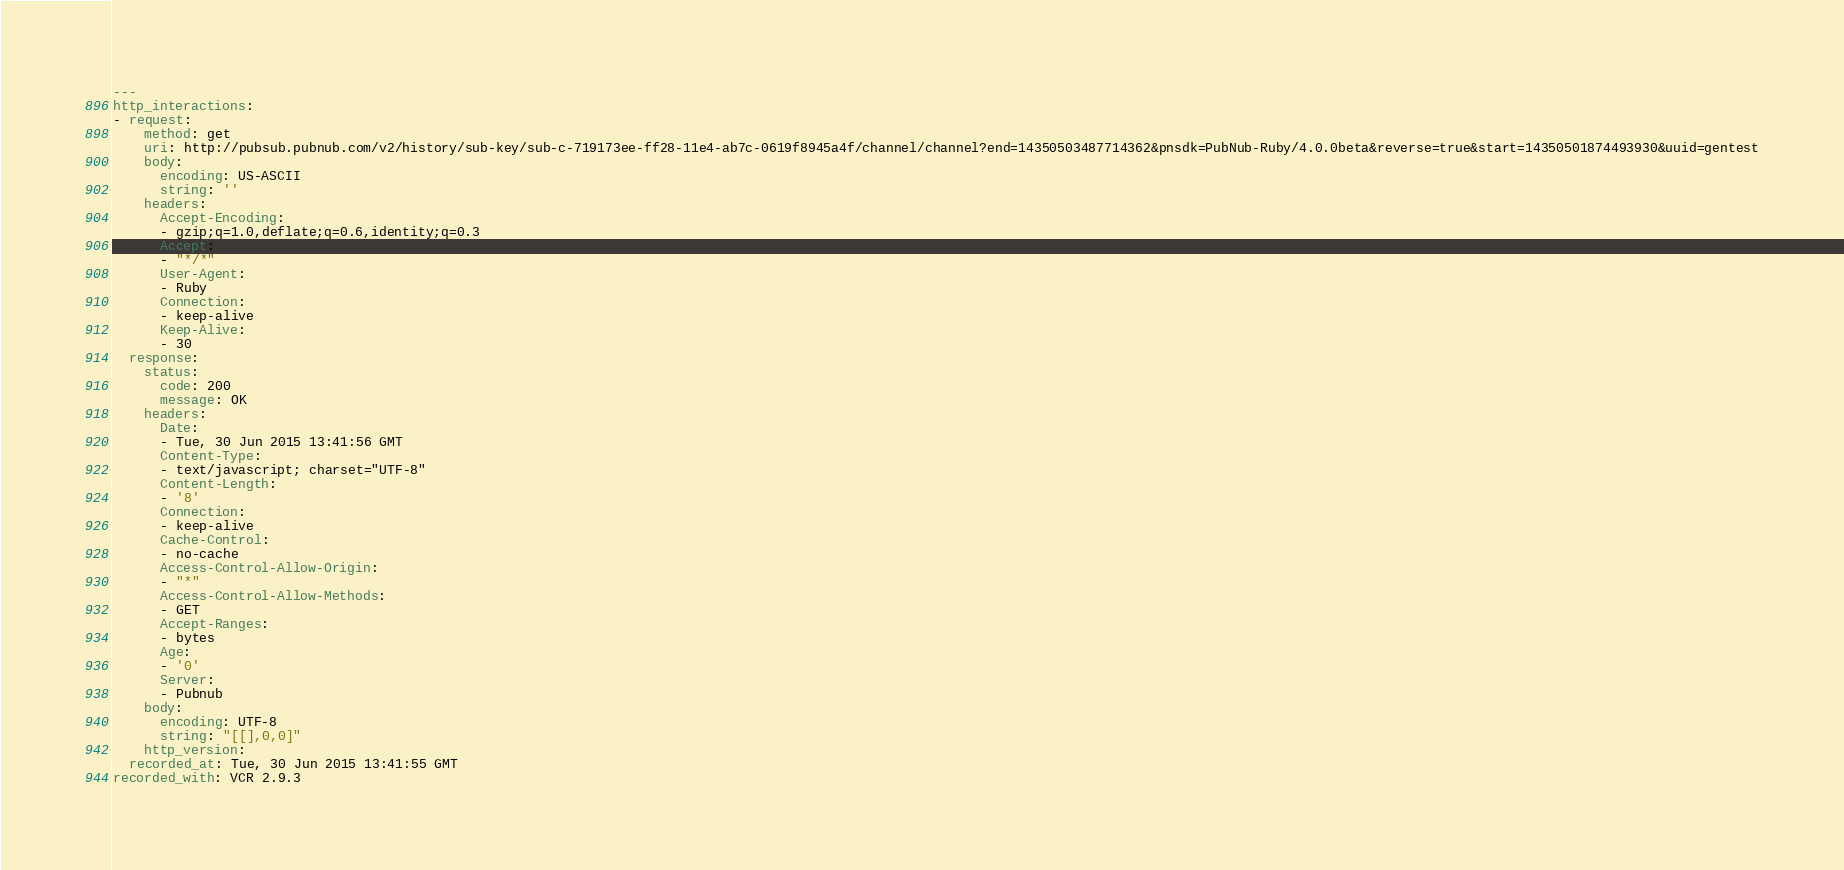<code> <loc_0><loc_0><loc_500><loc_500><_YAML_>---
http_interactions:
- request:
    method: get
    uri: http://pubsub.pubnub.com/v2/history/sub-key/sub-c-719173ee-ff28-11e4-ab7c-0619f8945a4f/channel/channel?end=14350503487714362&pnsdk=PubNub-Ruby/4.0.0beta&reverse=true&start=14350501874493930&uuid=gentest
    body:
      encoding: US-ASCII
      string: ''
    headers:
      Accept-Encoding:
      - gzip;q=1.0,deflate;q=0.6,identity;q=0.3
      Accept:
      - "*/*"
      User-Agent:
      - Ruby
      Connection:
      - keep-alive
      Keep-Alive:
      - 30
  response:
    status:
      code: 200
      message: OK
    headers:
      Date:
      - Tue, 30 Jun 2015 13:41:56 GMT
      Content-Type:
      - text/javascript; charset="UTF-8"
      Content-Length:
      - '8'
      Connection:
      - keep-alive
      Cache-Control:
      - no-cache
      Access-Control-Allow-Origin:
      - "*"
      Access-Control-Allow-Methods:
      - GET
      Accept-Ranges:
      - bytes
      Age:
      - '0'
      Server:
      - Pubnub
    body:
      encoding: UTF-8
      string: "[[],0,0]"
    http_version: 
  recorded_at: Tue, 30 Jun 2015 13:41:55 GMT
recorded_with: VCR 2.9.3
</code> 